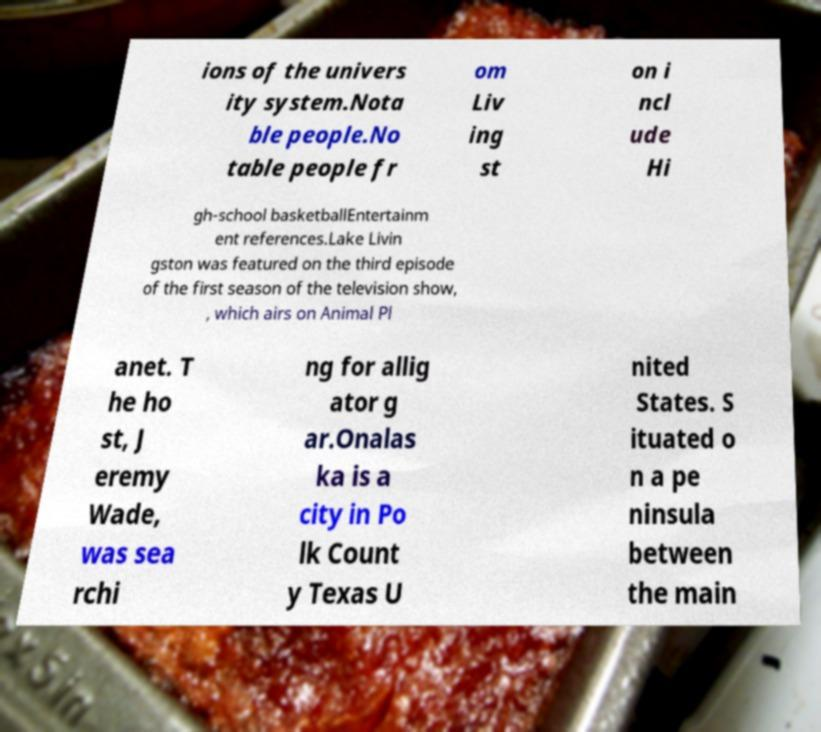For documentation purposes, I need the text within this image transcribed. Could you provide that? ions of the univers ity system.Nota ble people.No table people fr om Liv ing st on i ncl ude Hi gh-school basketballEntertainm ent references.Lake Livin gston was featured on the third episode of the first season of the television show, , which airs on Animal Pl anet. T he ho st, J eremy Wade, was sea rchi ng for allig ator g ar.Onalas ka is a city in Po lk Count y Texas U nited States. S ituated o n a pe ninsula between the main 